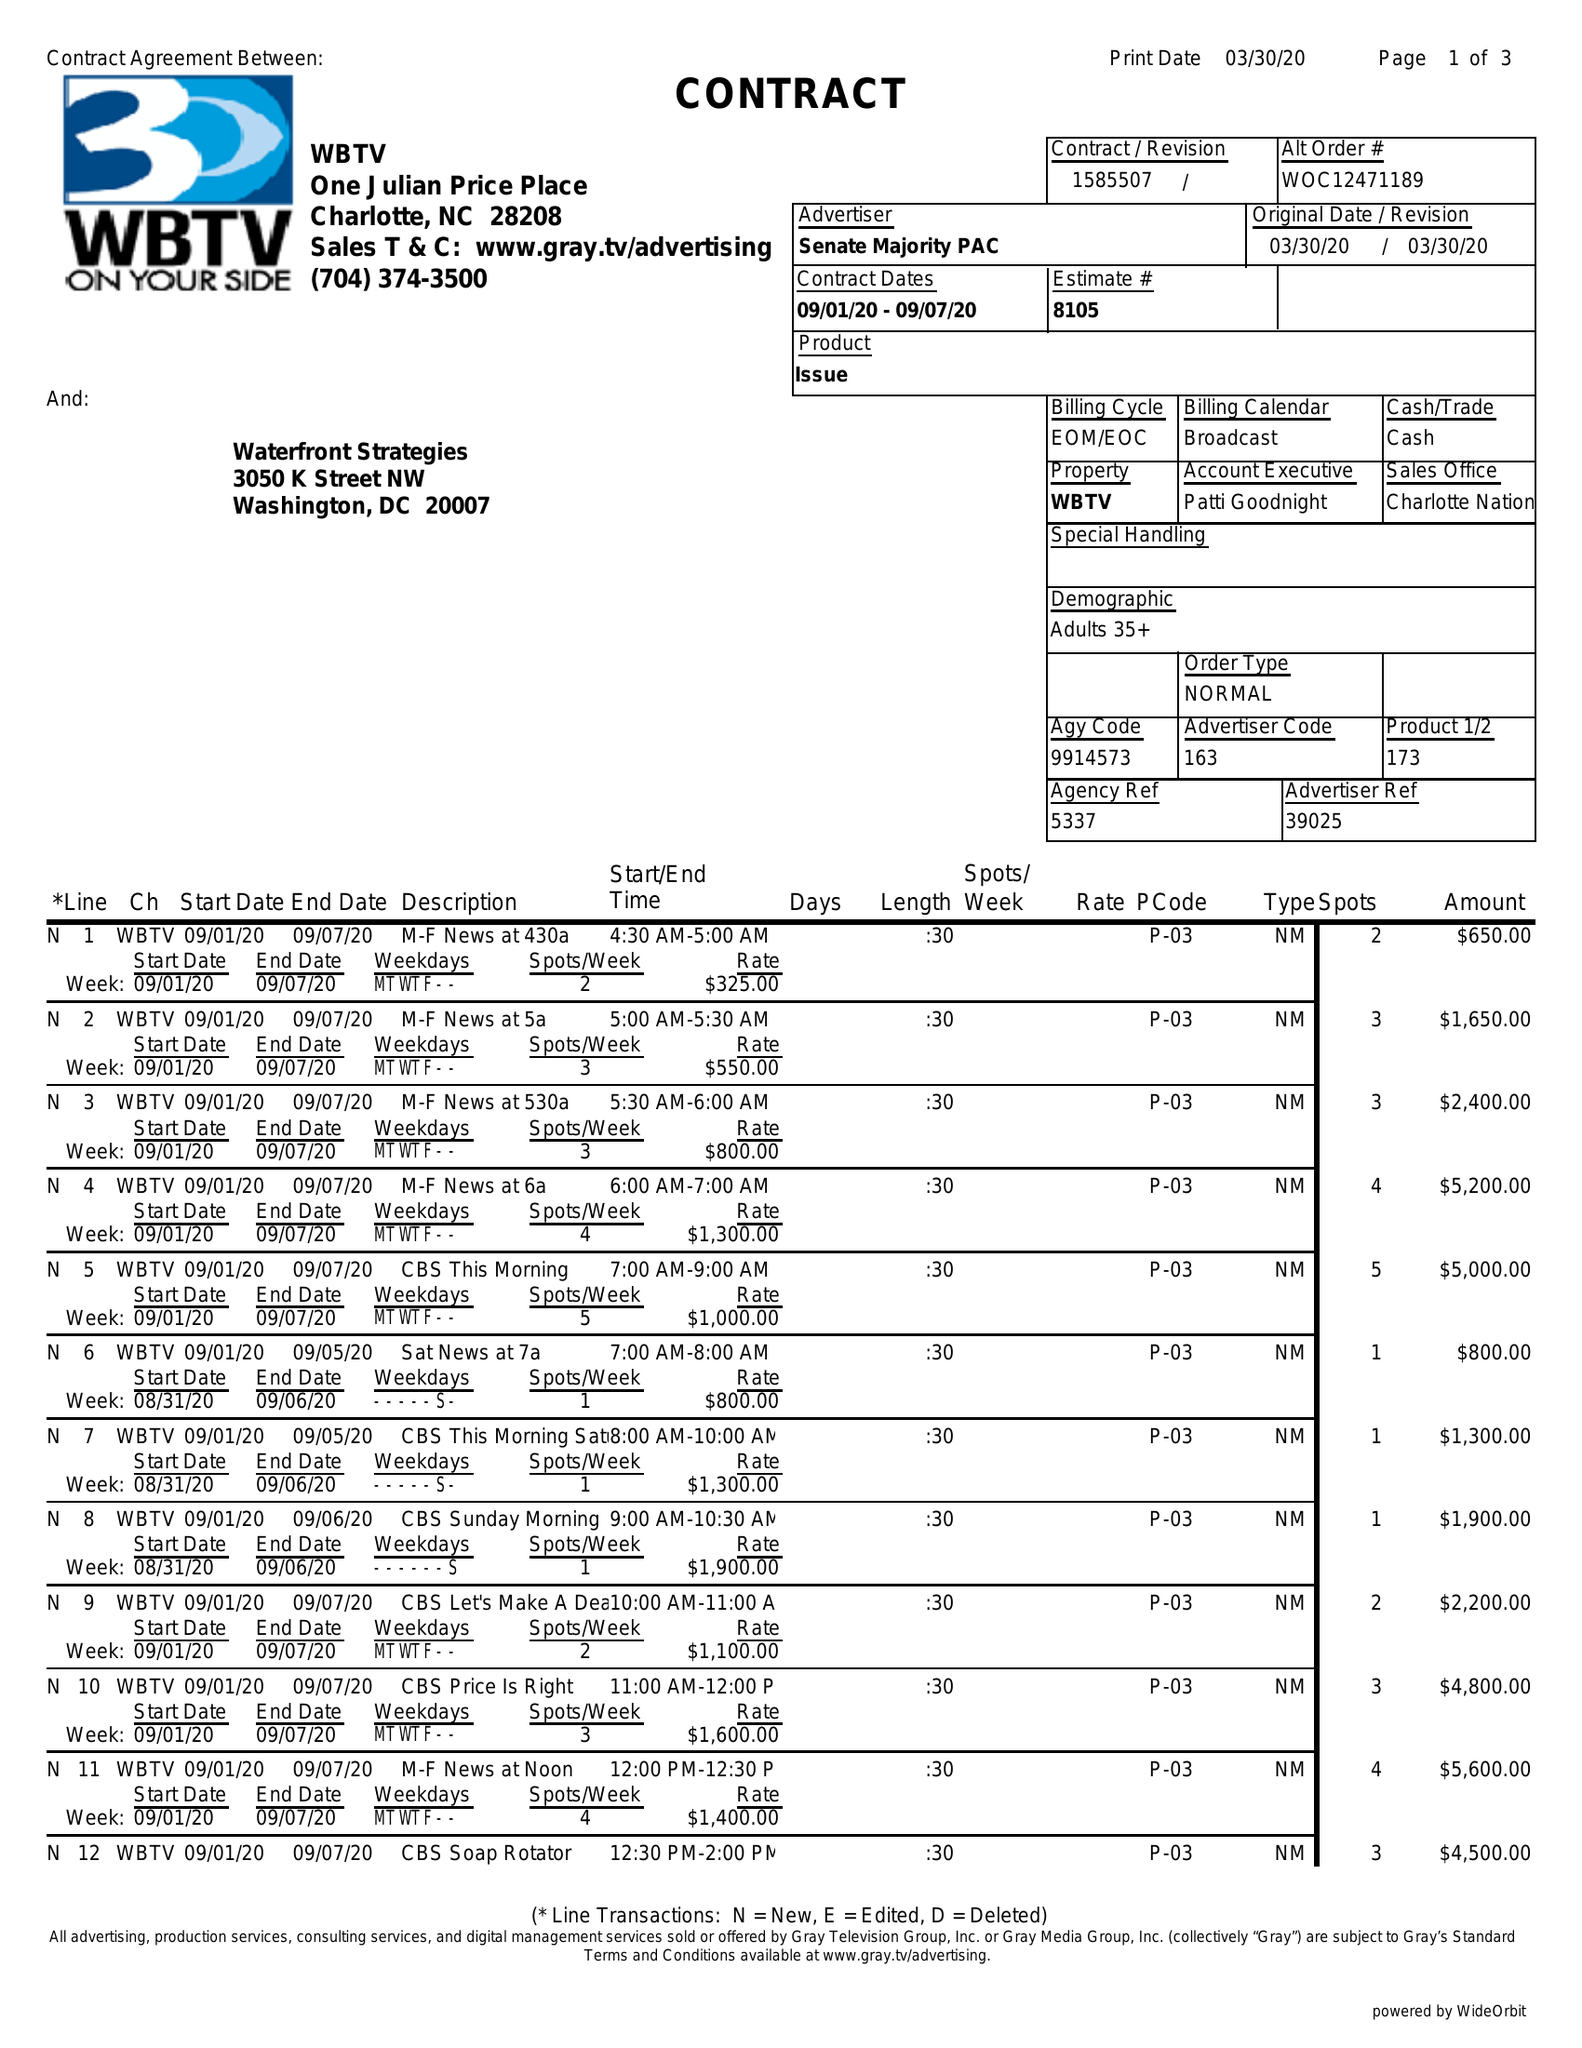What is the value for the gross_amount?
Answer the question using a single word or phrase. 97100.00 